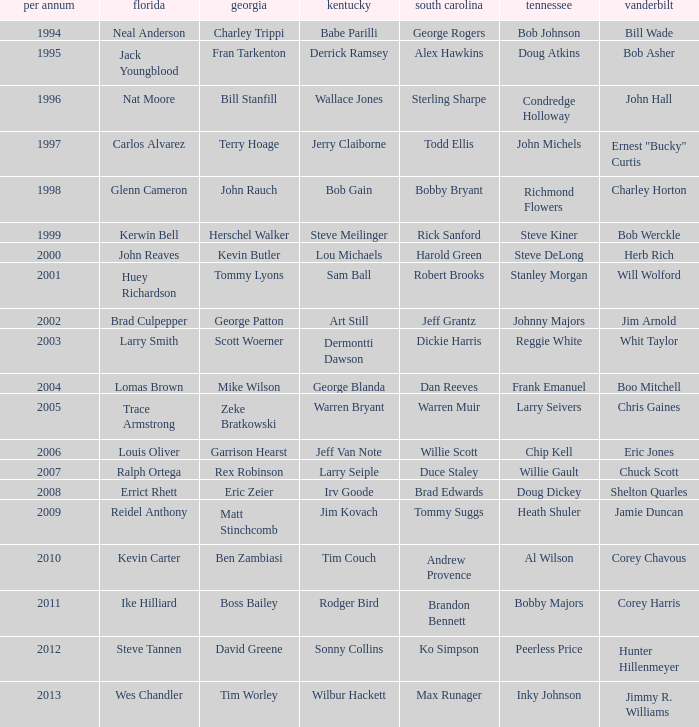What is the Tennessee with a Kentucky of Larry Seiple Willie Gault. 